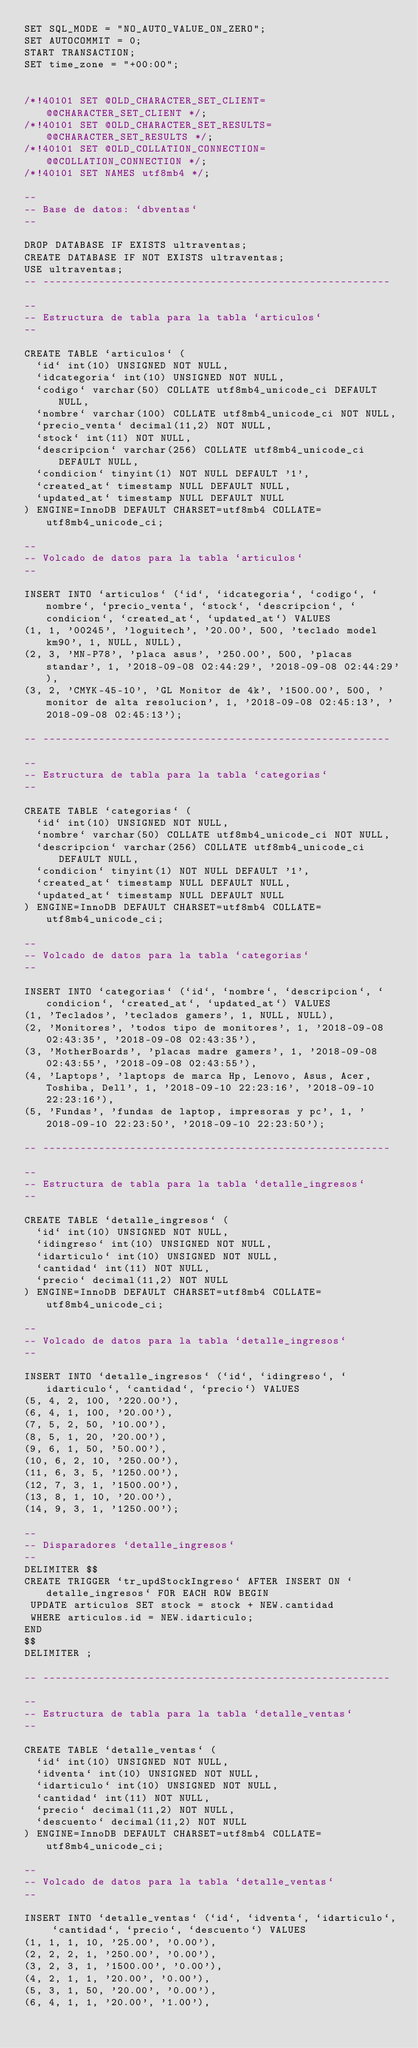Convert code to text. <code><loc_0><loc_0><loc_500><loc_500><_SQL_>SET SQL_MODE = "NO_AUTO_VALUE_ON_ZERO";
SET AUTOCOMMIT = 0;
START TRANSACTION;
SET time_zone = "+00:00";


/*!40101 SET @OLD_CHARACTER_SET_CLIENT=@@CHARACTER_SET_CLIENT */;
/*!40101 SET @OLD_CHARACTER_SET_RESULTS=@@CHARACTER_SET_RESULTS */;
/*!40101 SET @OLD_COLLATION_CONNECTION=@@COLLATION_CONNECTION */;
/*!40101 SET NAMES utf8mb4 */;

--
-- Base de datos: `dbventas`
--

DROP DATABASE IF EXISTS ultraventas;
CREATE DATABASE IF NOT EXISTS ultraventas;
USE ultraventas;
-- --------------------------------------------------------

--
-- Estructura de tabla para la tabla `articulos`
--

CREATE TABLE `articulos` (
  `id` int(10) UNSIGNED NOT NULL,
  `idcategoria` int(10) UNSIGNED NOT NULL,
  `codigo` varchar(50) COLLATE utf8mb4_unicode_ci DEFAULT NULL,
  `nombre` varchar(100) COLLATE utf8mb4_unicode_ci NOT NULL,
  `precio_venta` decimal(11,2) NOT NULL,
  `stock` int(11) NOT NULL,
  `descripcion` varchar(256) COLLATE utf8mb4_unicode_ci DEFAULT NULL,
  `condicion` tinyint(1) NOT NULL DEFAULT '1',
  `created_at` timestamp NULL DEFAULT NULL,
  `updated_at` timestamp NULL DEFAULT NULL
) ENGINE=InnoDB DEFAULT CHARSET=utf8mb4 COLLATE=utf8mb4_unicode_ci;

--
-- Volcado de datos para la tabla `articulos`
--

INSERT INTO `articulos` (`id`, `idcategoria`, `codigo`, `nombre`, `precio_venta`, `stock`, `descripcion`, `condicion`, `created_at`, `updated_at`) VALUES
(1, 1, '00245', 'loguitech', '20.00', 500, 'teclado model km90', 1, NULL, NULL),
(2, 3, 'MN-P78', 'placa asus', '250.00', 500, 'placas standar', 1, '2018-09-08 02:44:29', '2018-09-08 02:44:29'),
(3, 2, 'CMYK-45-10', 'GL Monitor de 4k', '1500.00', 500, 'monitor de alta resolucion', 1, '2018-09-08 02:45:13', '2018-09-08 02:45:13');

-- --------------------------------------------------------

--
-- Estructura de tabla para la tabla `categorias`
--

CREATE TABLE `categorias` (
  `id` int(10) UNSIGNED NOT NULL,
  `nombre` varchar(50) COLLATE utf8mb4_unicode_ci NOT NULL,
  `descripcion` varchar(256) COLLATE utf8mb4_unicode_ci DEFAULT NULL,
  `condicion` tinyint(1) NOT NULL DEFAULT '1',
  `created_at` timestamp NULL DEFAULT NULL,
  `updated_at` timestamp NULL DEFAULT NULL
) ENGINE=InnoDB DEFAULT CHARSET=utf8mb4 COLLATE=utf8mb4_unicode_ci;

--
-- Volcado de datos para la tabla `categorias`
--

INSERT INTO `categorias` (`id`, `nombre`, `descripcion`, `condicion`, `created_at`, `updated_at`) VALUES
(1, 'Teclados', 'teclados gamers', 1, NULL, NULL),
(2, 'Monitores', 'todos tipo de monitores', 1, '2018-09-08 02:43:35', '2018-09-08 02:43:35'),
(3, 'MotherBoards', 'placas madre gamers', 1, '2018-09-08 02:43:55', '2018-09-08 02:43:55'),
(4, 'Laptops', 'laptops de marca Hp, Lenovo, Asus, Acer, Toshiba, Dell', 1, '2018-09-10 22:23:16', '2018-09-10 22:23:16'),
(5, 'Fundas', 'fundas de laptop, impresoras y pc', 1, '2018-09-10 22:23:50', '2018-09-10 22:23:50');

-- --------------------------------------------------------

--
-- Estructura de tabla para la tabla `detalle_ingresos`
--

CREATE TABLE `detalle_ingresos` (
  `id` int(10) UNSIGNED NOT NULL,
  `idingreso` int(10) UNSIGNED NOT NULL,
  `idarticulo` int(10) UNSIGNED NOT NULL,
  `cantidad` int(11) NOT NULL,
  `precio` decimal(11,2) NOT NULL
) ENGINE=InnoDB DEFAULT CHARSET=utf8mb4 COLLATE=utf8mb4_unicode_ci;

--
-- Volcado de datos para la tabla `detalle_ingresos`
--

INSERT INTO `detalle_ingresos` (`id`, `idingreso`, `idarticulo`, `cantidad`, `precio`) VALUES
(5, 4, 2, 100, '220.00'),
(6, 4, 1, 100, '20.00'),
(7, 5, 2, 50, '10.00'),
(8, 5, 1, 20, '20.00'),
(9, 6, 1, 50, '50.00'),
(10, 6, 2, 10, '250.00'),
(11, 6, 3, 5, '1250.00'),
(12, 7, 3, 1, '1500.00'),
(13, 8, 1, 10, '20.00'),
(14, 9, 3, 1, '1250.00');

--
-- Disparadores `detalle_ingresos`
--
DELIMITER $$
CREATE TRIGGER `tr_updStockIngreso` AFTER INSERT ON `detalle_ingresos` FOR EACH ROW BEGIN
 UPDATE articulos SET stock = stock + NEW.cantidad 
 WHERE articulos.id = NEW.idarticulo;
END
$$
DELIMITER ;

-- --------------------------------------------------------

--
-- Estructura de tabla para la tabla `detalle_ventas`
--

CREATE TABLE `detalle_ventas` (
  `id` int(10) UNSIGNED NOT NULL,
  `idventa` int(10) UNSIGNED NOT NULL,
  `idarticulo` int(10) UNSIGNED NOT NULL,
  `cantidad` int(11) NOT NULL,
  `precio` decimal(11,2) NOT NULL,
  `descuento` decimal(11,2) NOT NULL
) ENGINE=InnoDB DEFAULT CHARSET=utf8mb4 COLLATE=utf8mb4_unicode_ci;

--
-- Volcado de datos para la tabla `detalle_ventas`
--

INSERT INTO `detalle_ventas` (`id`, `idventa`, `idarticulo`, `cantidad`, `precio`, `descuento`) VALUES
(1, 1, 1, 10, '25.00', '0.00'),
(2, 2, 2, 1, '250.00', '0.00'),
(3, 2, 3, 1, '1500.00', '0.00'),
(4, 2, 1, 1, '20.00', '0.00'),
(5, 3, 1, 50, '20.00', '0.00'),
(6, 4, 1, 1, '20.00', '1.00'),</code> 